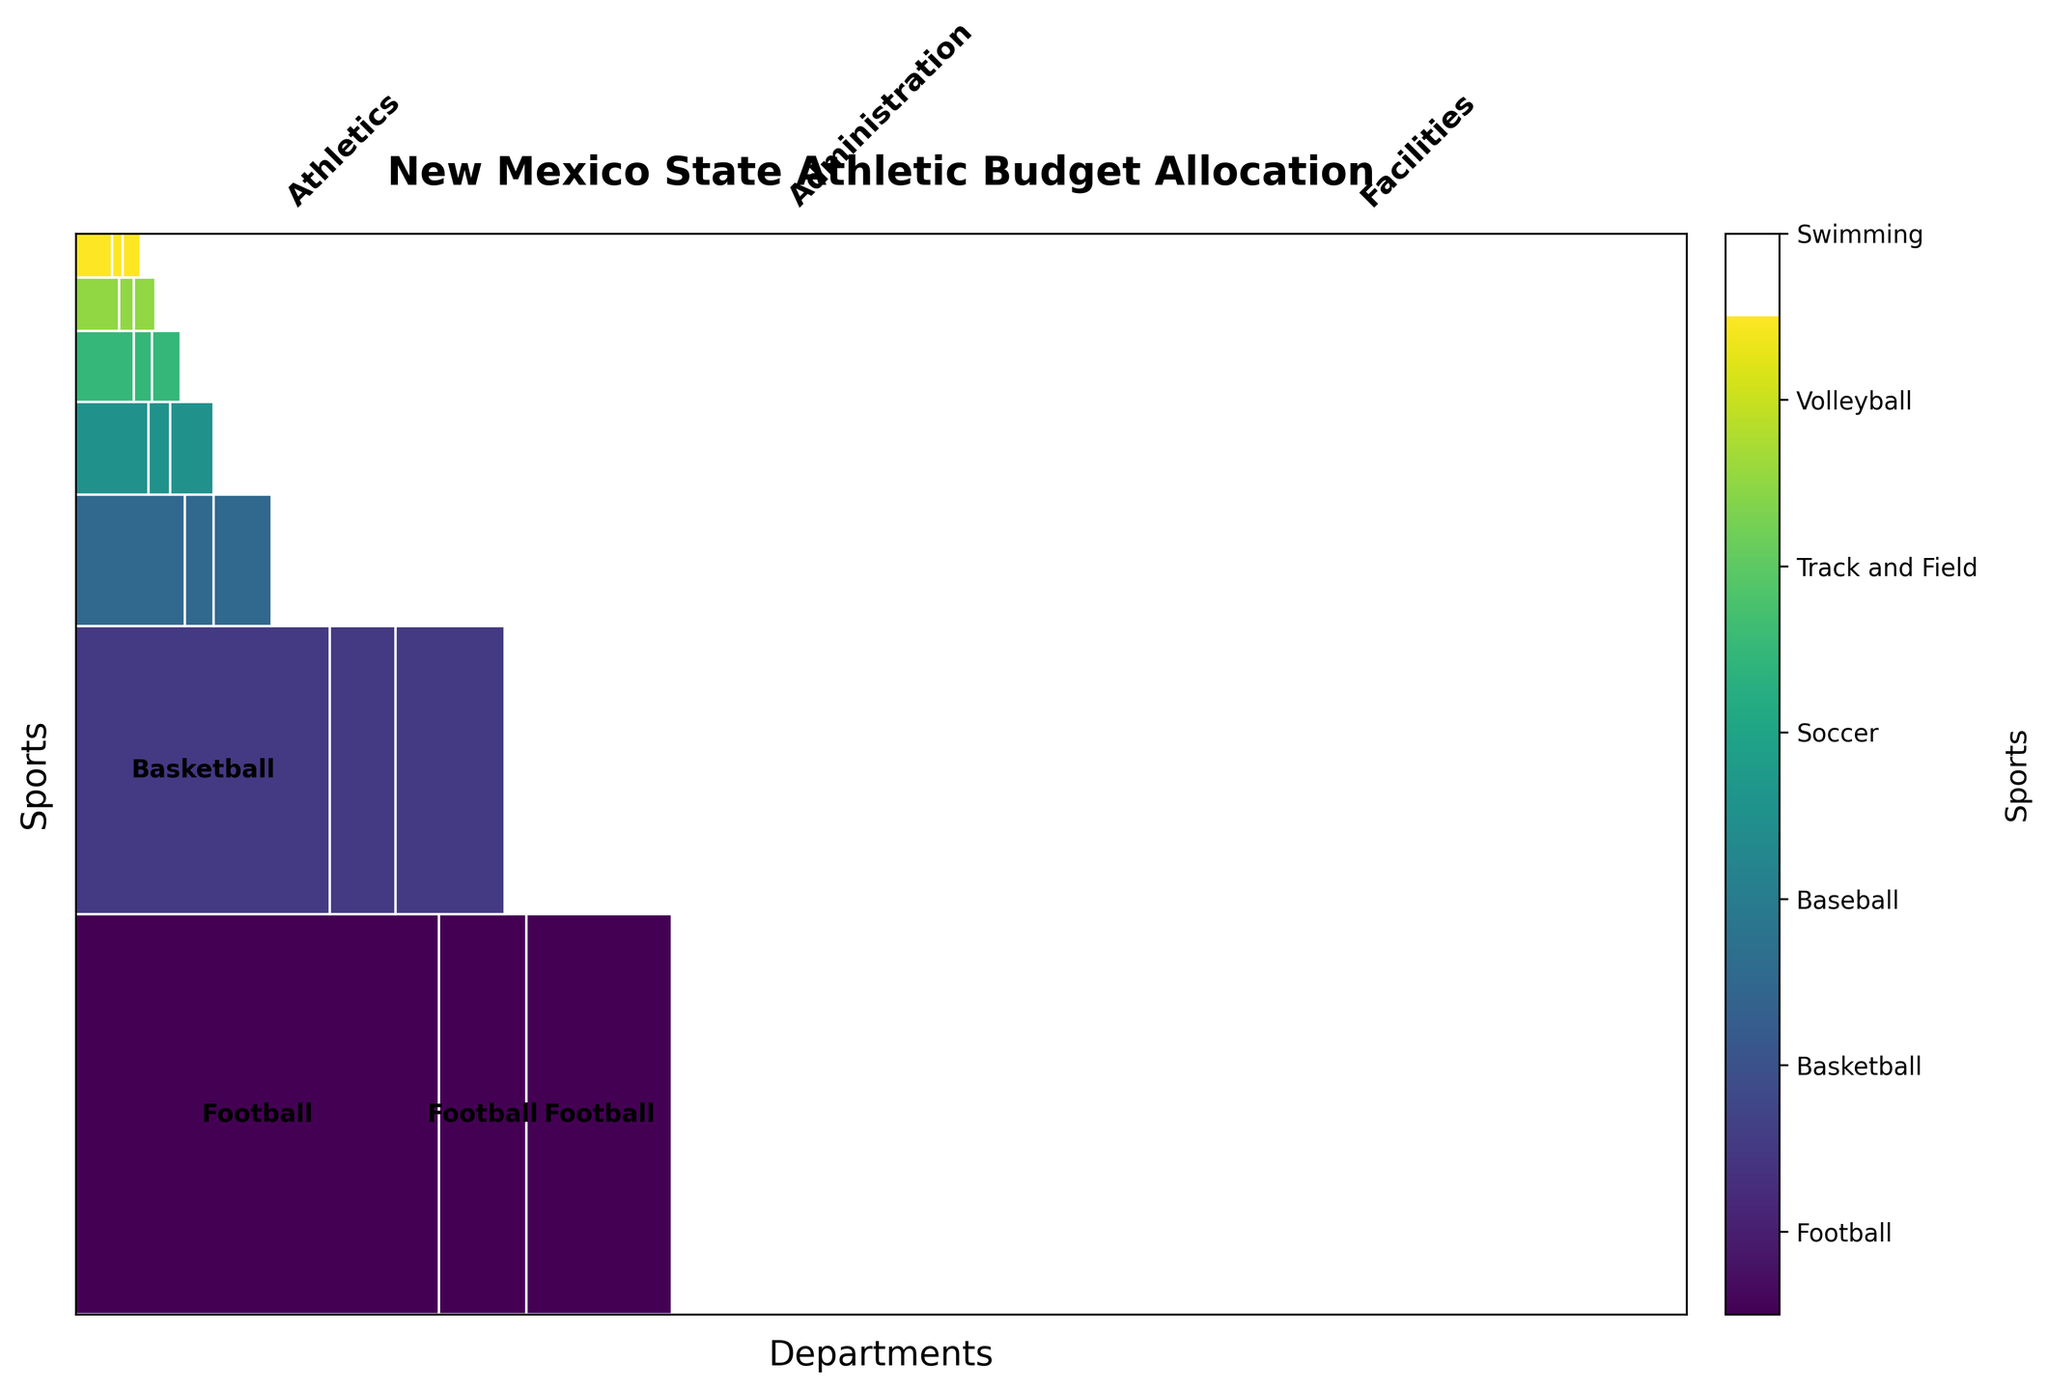What is the title of the mosaic plot? The title is at the top of the figure in large, bold font. It reads "New Mexico State Athletic Budget Allocation."
Answer: New Mexico State Athletic Budget Allocation How many sports are included in the budget allocation? By looking at the color bar legend on the right side of the figure, you can count the unique sports listed. These are Football, Basketball, Baseball, Soccer, Track and Field, Volleyball, and Swimming.
Answer: 7 Which sport has the largest budget allocation within the Athletics department? In the Athletics section of the plot, the largest rectangle among sports cells belongs to Football, indicating it has the biggest budget allocation.
Answer: Football What is the smallest department allocation for Soccer? By examining all three departments (Athletics, Administration, Facilities) and comparing their Soccer allocations visually from left to right, the smallest rectangle belongs to the Administration department.
Answer: Administration Which department allocates the most budget for Basketball? By comparing the rectangles for Basketball across Athletics, Administration, and Facilities, the largest rectangle is in the Athletics section to the left.
Answer: Athletics Compare the budget allocation for Volleyball in the Athletics and Facilities departments. Which is larger? Look at both rectangles for Volleyball in the Athletics and Facilities sections. The rectangle in the Athletics section is bigger compared to the one in the Facilities section.
Answer: Athletics Is the budget allocation for Swimming larger in Facilities or Administration? By observing the rectangles for Swimming in Facilities and Administration, the rectangle in Facilities is larger compared to Administration.
Answer: Facilities Which pair of sports have similar budget allocations in the Athletics department? By visually comparing the sizes of the rectangles in the Athletics section, Track and Field and Volleyball have similarly sized rectangles indicating similar allocations.
Answer: Track and Field and Volleyball What is the total budget allocation for Football across all departments? Sum the widths of the rectangles for Football in Athletics, Administration, and Facilities sections. The Football rectangles are largest and easily identifiable.
Answer: 8,200,000 Among the three departments, which allocates the least towards the Track and Field program? Compare the sizes of the Track and Field rectangles across Athletics, Administration, and Facilities. The smallest one is found in the Administration section.
Answer: Administration 